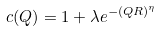Convert formula to latex. <formula><loc_0><loc_0><loc_500><loc_500>c ( Q ) = 1 + \lambda e ^ { - ( Q R ) ^ { \eta } }</formula> 